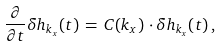<formula> <loc_0><loc_0><loc_500><loc_500>\frac { \partial } { \partial t } \delta { h } _ { k _ { x } } ( t ) \, = \, { C } ( k _ { x } ) \, \cdot \delta { h } _ { k _ { x } } ( t ) \, ,</formula> 